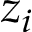Convert formula to latex. <formula><loc_0><loc_0><loc_500><loc_500>z _ { i }</formula> 